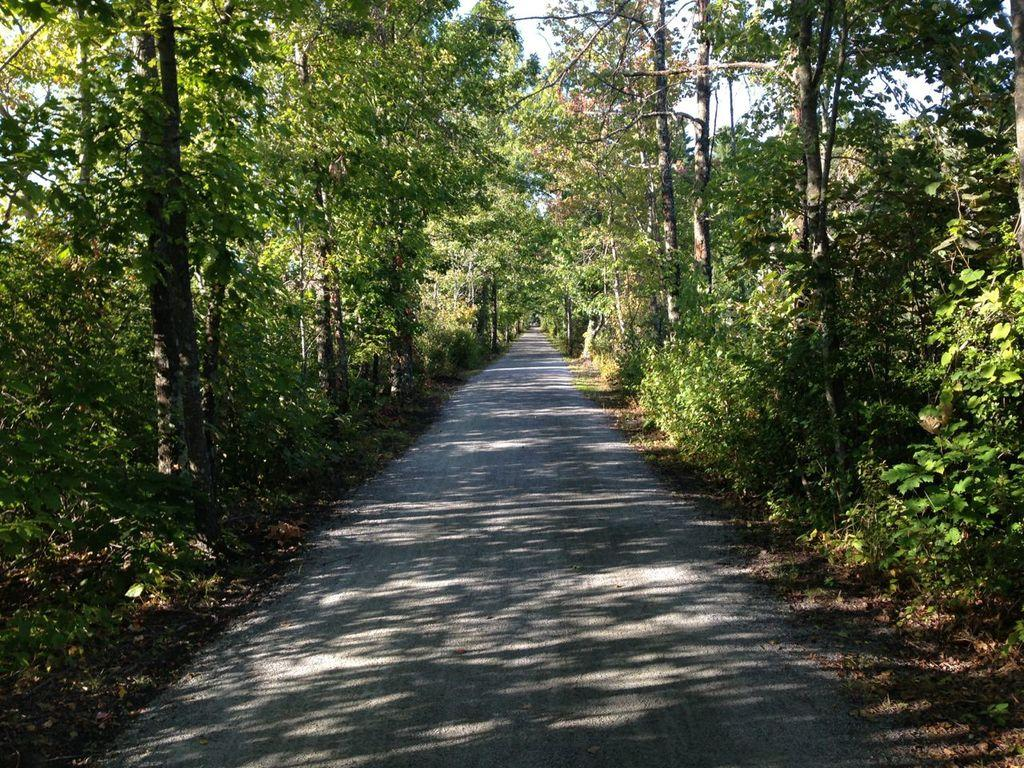What is the main feature of the image? There is a road in the image. What can be seen on the left side of the image? There are trees on the left side of the image. What can be seen on the right side of the image? There are trees on the right side of the image. What type of disease is affecting the trees on the left side of the image? There is no indication of any disease affecting the trees in the image. 